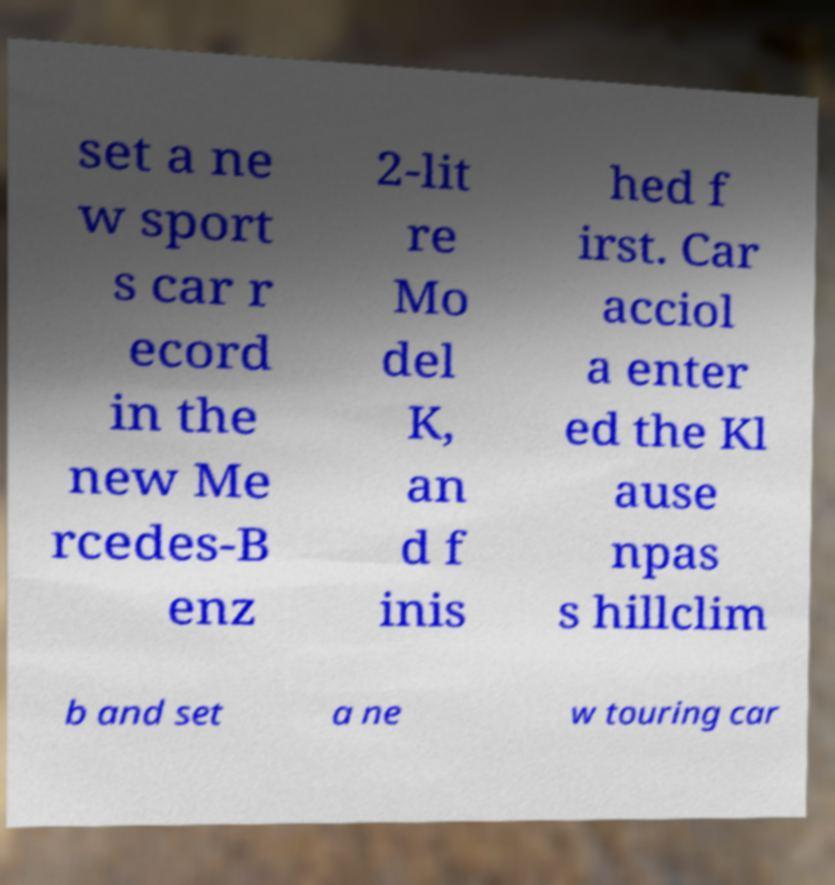Please identify and transcribe the text found in this image. set a ne w sport s car r ecord in the new Me rcedes-B enz 2-lit re Mo del K, an d f inis hed f irst. Car acciol a enter ed the Kl ause npas s hillclim b and set a ne w touring car 